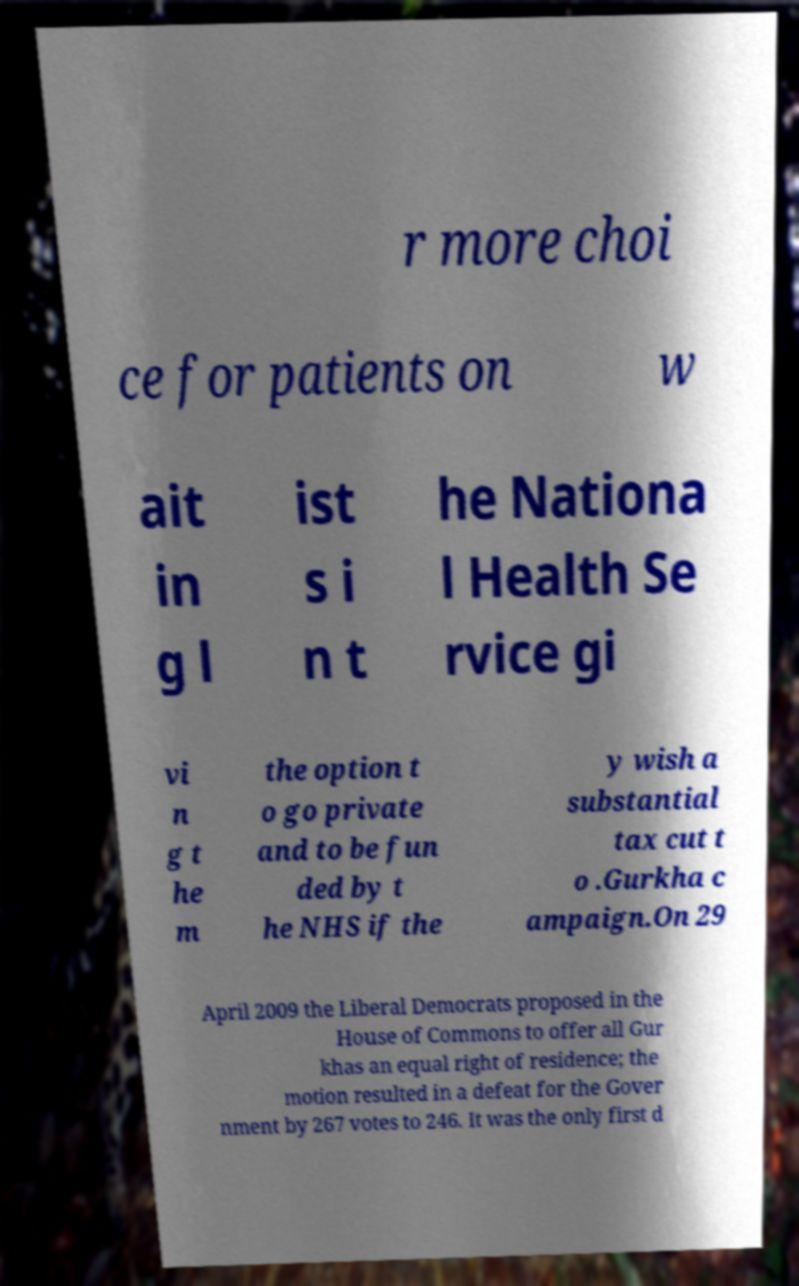Can you accurately transcribe the text from the provided image for me? r more choi ce for patients on w ait in g l ist s i n t he Nationa l Health Se rvice gi vi n g t he m the option t o go private and to be fun ded by t he NHS if the y wish a substantial tax cut t o .Gurkha c ampaign.On 29 April 2009 the Liberal Democrats proposed in the House of Commons to offer all Gur khas an equal right of residence; the motion resulted in a defeat for the Gover nment by 267 votes to 246. It was the only first d 